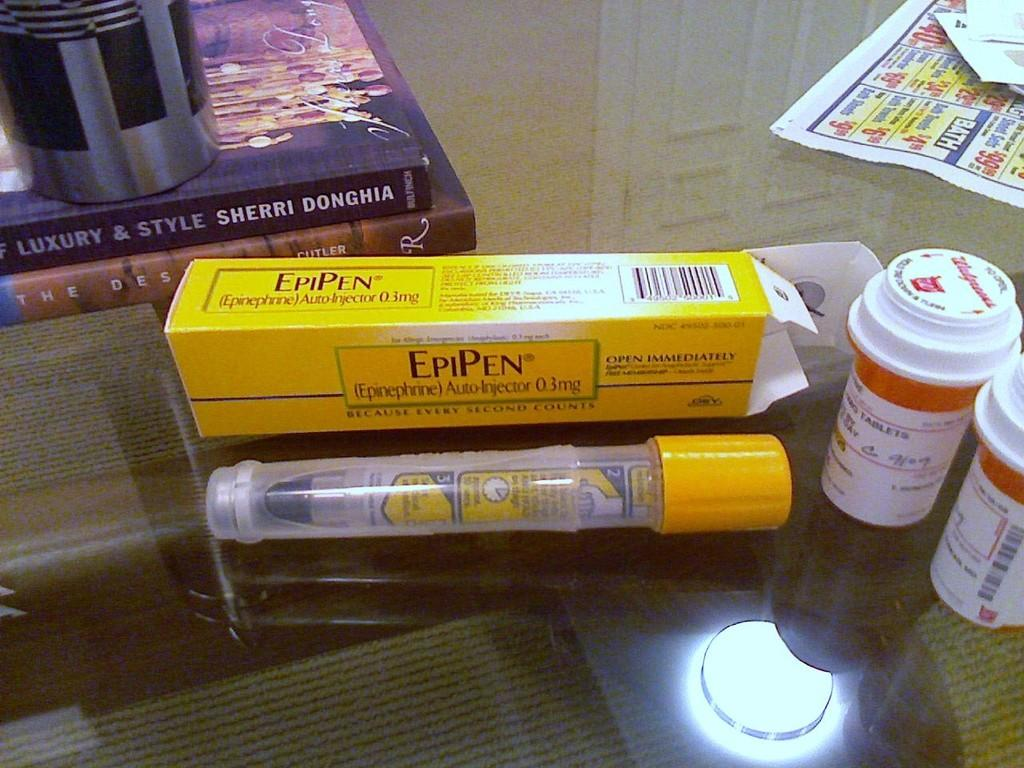<image>
Provide a brief description of the given image. An open box of EpiPen with the pen and other bottles of medication lying on a table. 